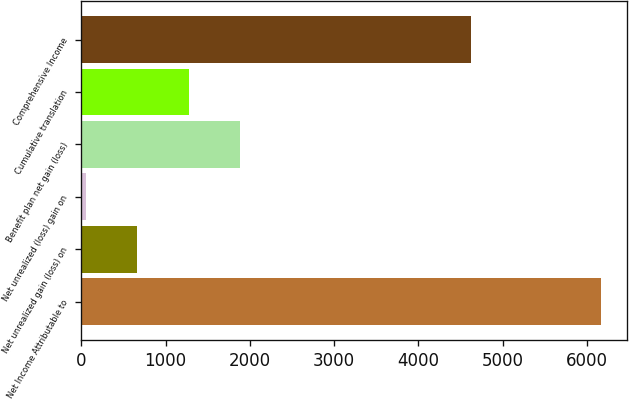Convert chart to OTSL. <chart><loc_0><loc_0><loc_500><loc_500><bar_chart><fcel>Net Income Attributable to<fcel>Net unrealized gain (loss) on<fcel>Net unrealized (loss) gain on<fcel>Benefit plan net gain (loss)<fcel>Cumulative translation<fcel>Comprehensive Income<nl><fcel>6168<fcel>663.6<fcel>52<fcel>1886.8<fcel>1275.2<fcel>4618<nl></chart> 